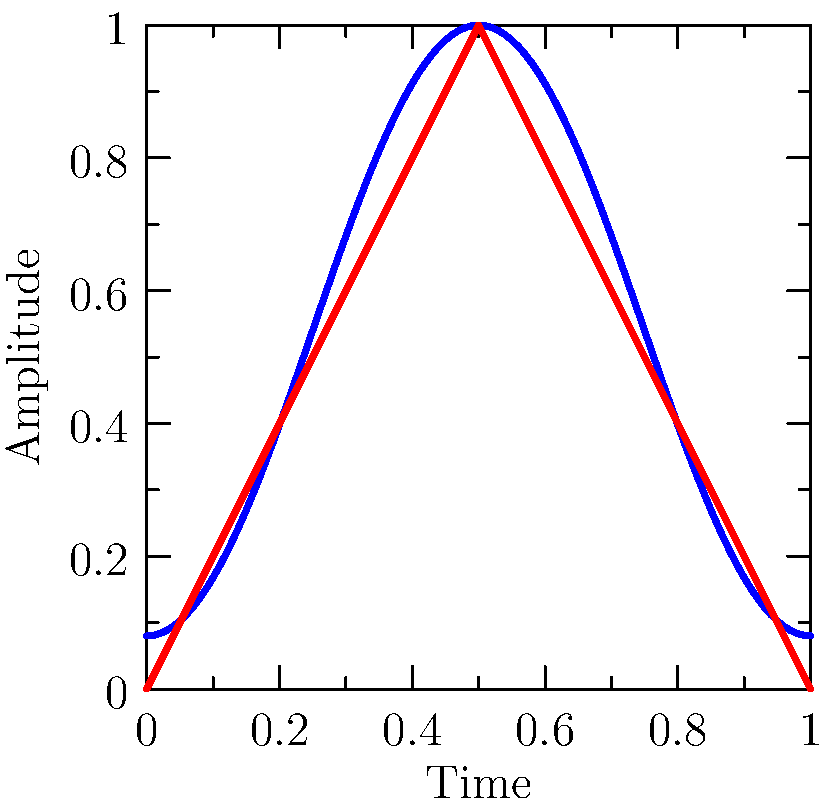Consider the Hamming and Triangular windowing functions shown in the graph. Which of these functions would be more suitable for analyzing speech signals with closely spaced frequency components, and why? To answer this question, we need to consider the properties of both windowing functions and their effects on spectral analysis:

1. Hamming window:
   - Equation: $w(n) = 0.54 - 0.46 \cos(\frac{2\pi n}{N-1})$
   - Better side-lobe suppression (about -43 dB)
   - Wider main lobe

2. Triangular window:
   - Equation: $w(n) = 1 - |\frac{2n}{N-1} - 1|$
   - Poorer side-lobe suppression (about -26 dB)
   - Narrower main lobe

3. For speech signals with closely spaced frequency components:
   - We need better frequency resolution to distinguish between close frequencies
   - A narrower main lobe provides better frequency resolution
   - Side-lobe suppression is less critical for closely spaced components

4. Comparing the windows:
   - The Triangular window has a narrower main lobe, offering better frequency resolution
   - The Hamming window has better side-lobe suppression but at the cost of a wider main lobe

5. Conclusion:
   - The Triangular window would be more suitable for analyzing speech signals with closely spaced frequency components due to its narrower main lobe, which provides better frequency resolution.
Answer: Triangular window, due to its narrower main lobe providing better frequency resolution for closely spaced components. 